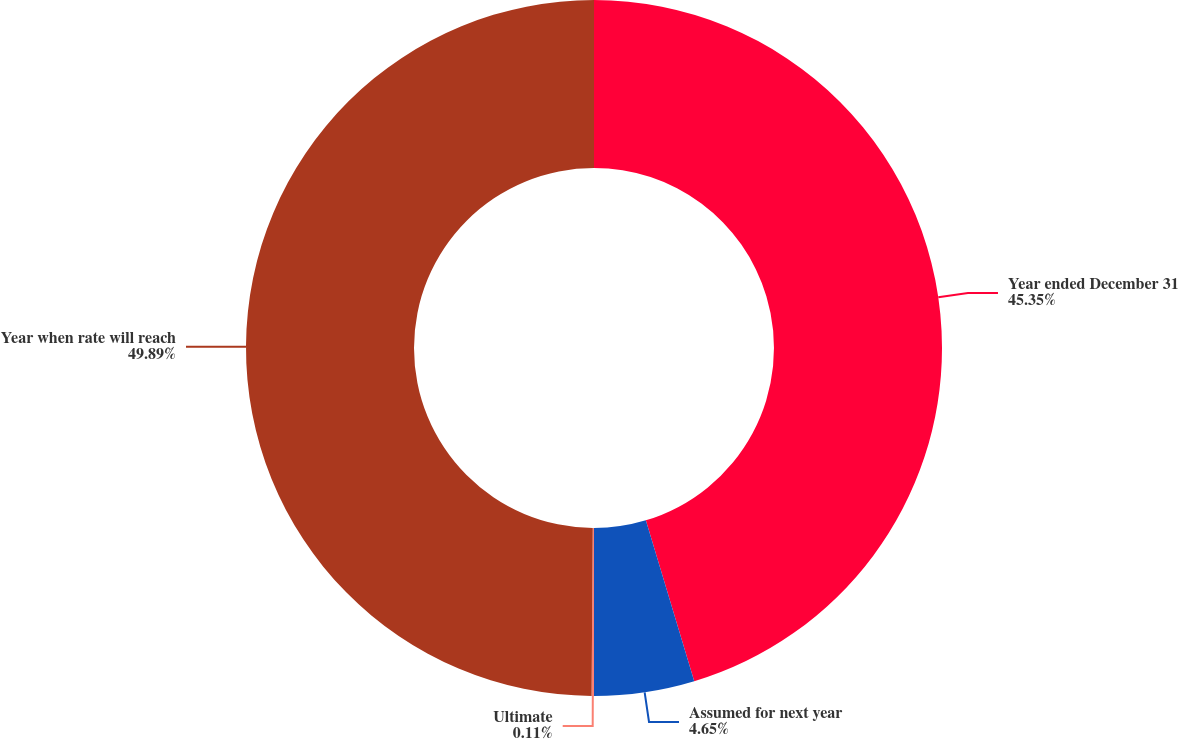Convert chart. <chart><loc_0><loc_0><loc_500><loc_500><pie_chart><fcel>Year ended December 31<fcel>Assumed for next year<fcel>Ultimate<fcel>Year when rate will reach<nl><fcel>45.35%<fcel>4.65%<fcel>0.11%<fcel>49.89%<nl></chart> 